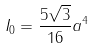Convert formula to latex. <formula><loc_0><loc_0><loc_500><loc_500>I _ { 0 } = \frac { 5 \sqrt { 3 } } { 1 6 } a ^ { 4 }</formula> 